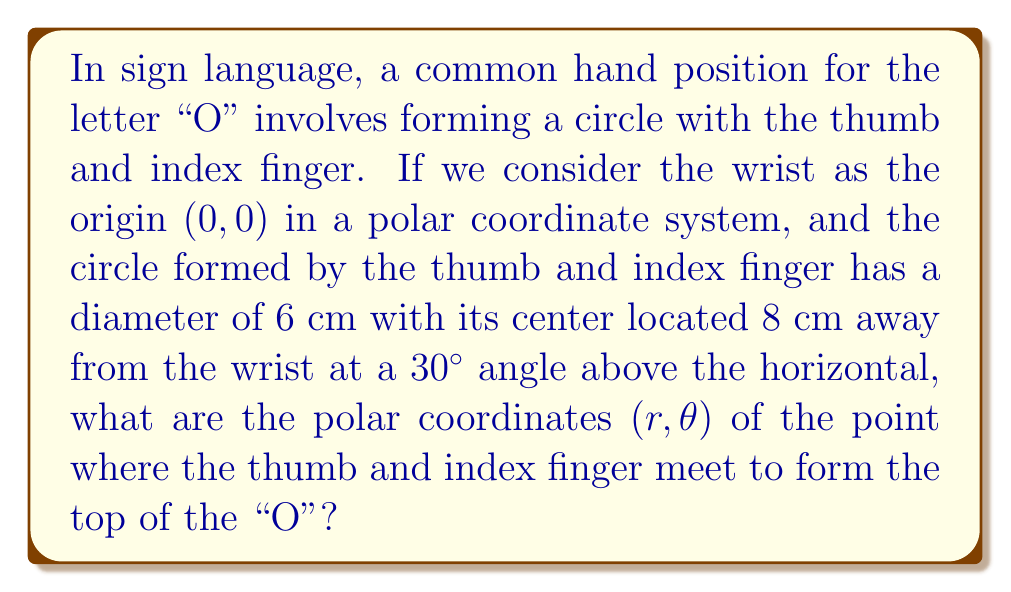Show me your answer to this math problem. Let's approach this step-by-step:

1) First, we need to find the center of the circle in polar coordinates. We're given that it's 8 cm away from the wrist at a 30° angle:
   
   $r_{\text{center}} = 8$ cm
   $\theta_{\text{center}} = 30°$

2) The diameter of the circle is 6 cm, so the radius is 3 cm.

3) The point where the thumb and index finger meet is at the top of this circle. This point is 3 cm (the radius) further away from the wrist than the center, and at a slightly larger angle.

4) To find the r-coordinate of this point, we can use the law of cosines:

   $$r^2 = 8^2 + 3^2 - 2(8)(3)\cos(90°) = 64 + 9 = 73$$
   
   $$r = \sqrt{73} \approx 8.544 \text{ cm}$$

5) To find the θ-coordinate, we can use the law of sines:

   $$\sin(\theta - 30°) = \frac{3\sin(90°)}{8.544}$$
   
   $$\theta - 30° = \arcsin(\frac{3}{8.544}) \approx 20.66°$$
   
   $$\theta \approx 50.66°$$

Therefore, the polar coordinates of the point where the thumb and index finger meet are approximately (8.544 cm, 50.66°).
Answer: $(r, \theta) \approx (8.544 \text{ cm}, 50.66°)$ 